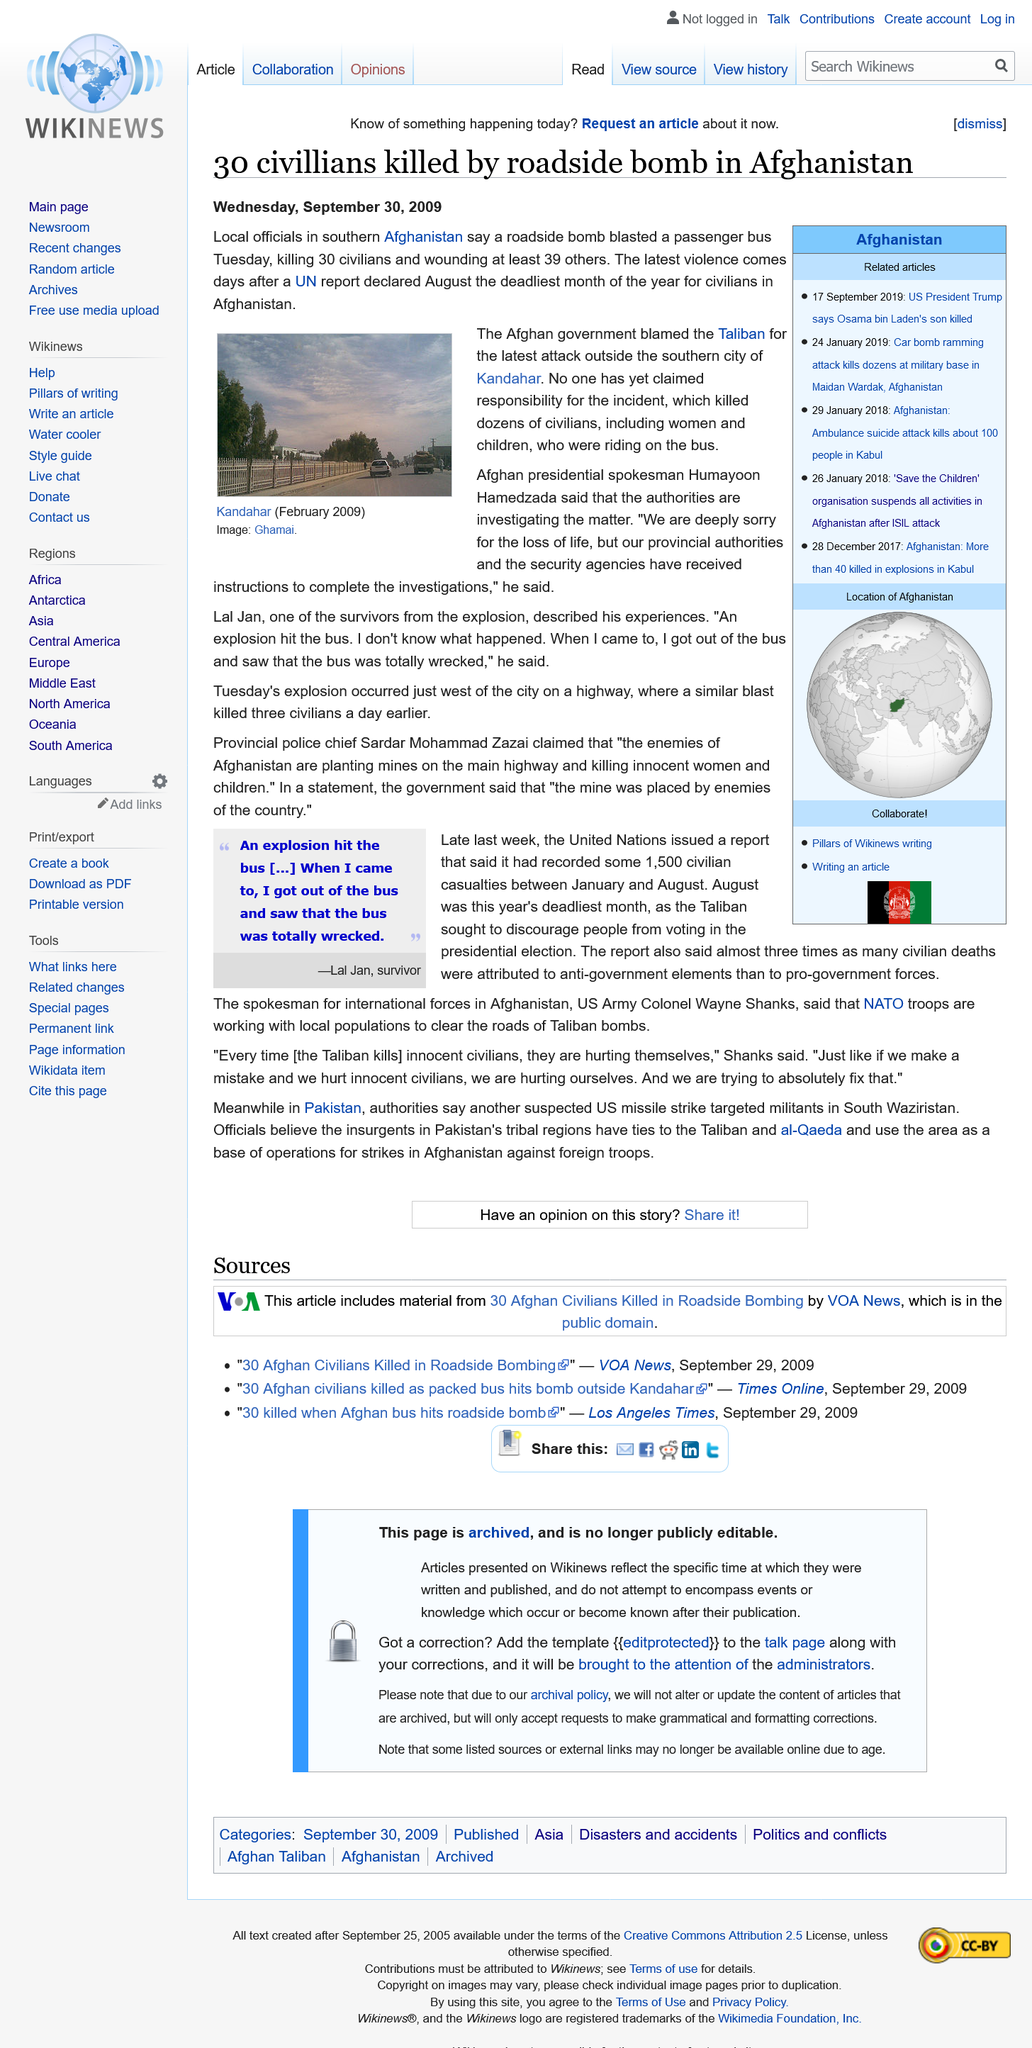Outline some significant characteristics in this image. August, as declared by the United Nations, is the deadliest month of the year for civilians in Afghanistan. Thirty civilians were killed and injured in a roadside bomb blast that occurred outside the city of Kandahar. 